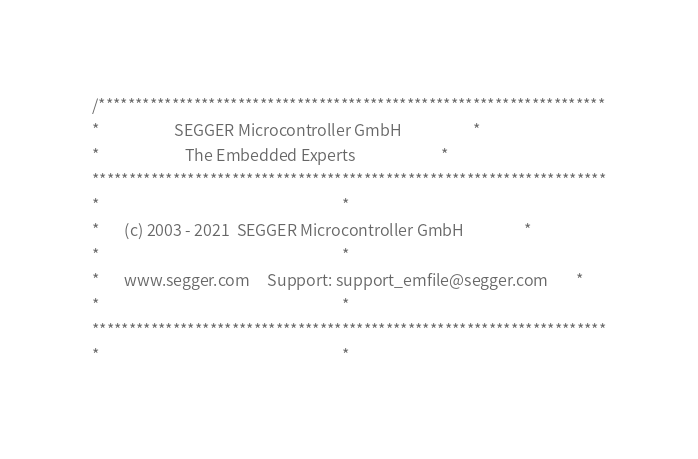Convert code to text. <code><loc_0><loc_0><loc_500><loc_500><_C_>/*********************************************************************
*                     SEGGER Microcontroller GmbH                    *
*                        The Embedded Experts                        *
**********************************************************************
*                                                                    *
*       (c) 2003 - 2021  SEGGER Microcontroller GmbH                 *
*                                                                    *
*       www.segger.com     Support: support_emfile@segger.com        *
*                                                                    *
**********************************************************************
*                                                                    *</code> 